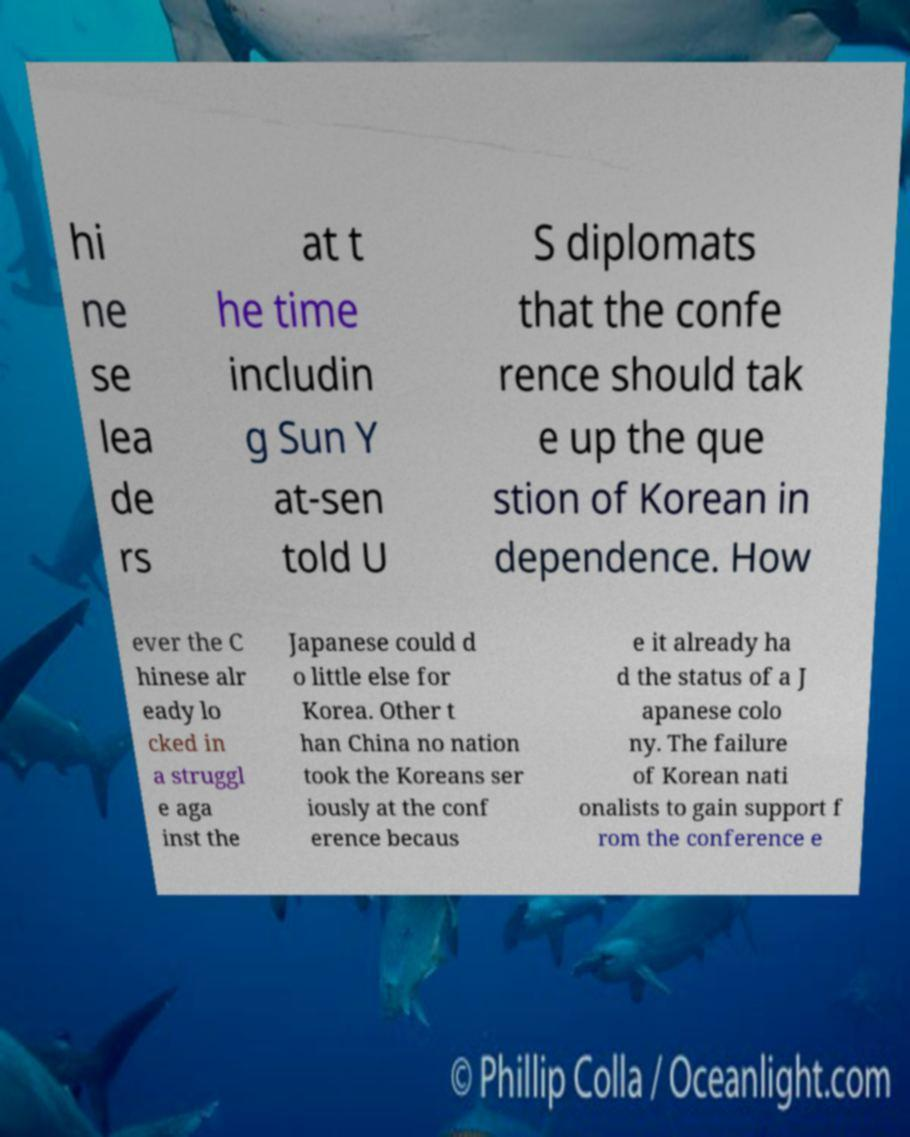Could you extract and type out the text from this image? hi ne se lea de rs at t he time includin g Sun Y at-sen told U S diplomats that the confe rence should tak e up the que stion of Korean in dependence. How ever the C hinese alr eady lo cked in a struggl e aga inst the Japanese could d o little else for Korea. Other t han China no nation took the Koreans ser iously at the conf erence becaus e it already ha d the status of a J apanese colo ny. The failure of Korean nati onalists to gain support f rom the conference e 